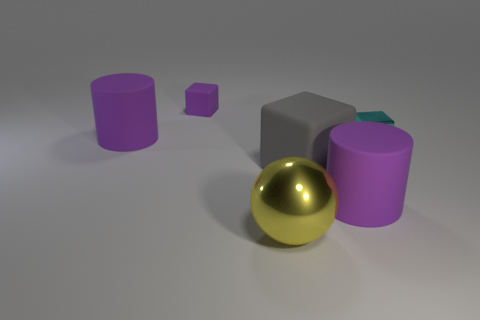Does the small purple block have the same material as the cylinder that is left of the yellow metal thing?
Offer a very short reply. Yes. The purple object that is the same shape as the cyan thing is what size?
Your answer should be compact. Small. Is the number of matte cubes to the right of the yellow shiny thing the same as the number of big matte cylinders in front of the big gray rubber block?
Offer a very short reply. Yes. What number of other objects are there of the same material as the big gray block?
Offer a very short reply. 3. Are there an equal number of cyan metal blocks right of the small cyan cube and purple metal blocks?
Offer a terse response. Yes. There is a cyan shiny cube; is its size the same as the cube that is behind the tiny cyan metallic block?
Provide a succinct answer. Yes. What shape is the tiny thing that is left of the large metal thing?
Give a very brief answer. Cube. Are there any other things that are the same shape as the gray thing?
Make the answer very short. Yes. Are there any metal balls?
Offer a very short reply. Yes. Is the size of the purple object on the left side of the purple matte block the same as the block that is on the right side of the gray rubber object?
Your response must be concise. No. 